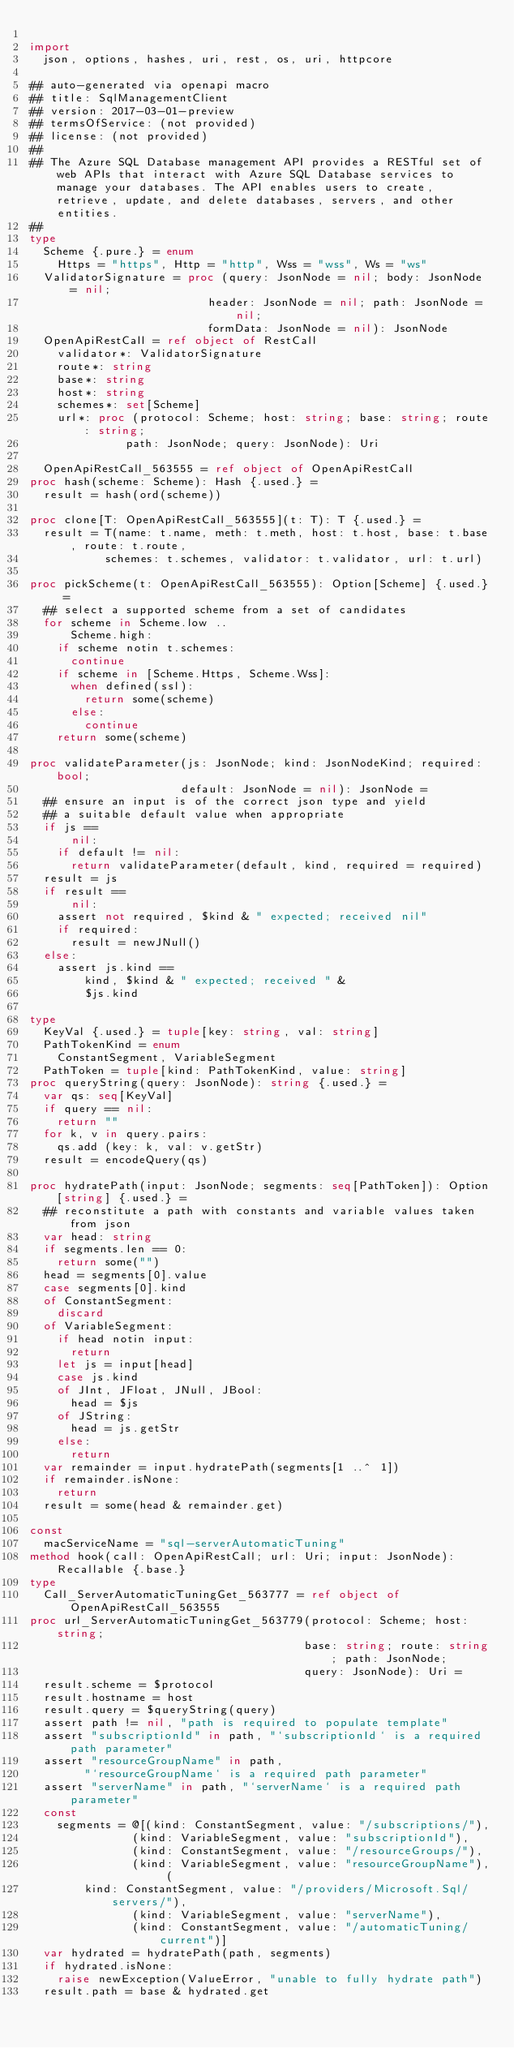<code> <loc_0><loc_0><loc_500><loc_500><_Nim_>
import
  json, options, hashes, uri, rest, os, uri, httpcore

## auto-generated via openapi macro
## title: SqlManagementClient
## version: 2017-03-01-preview
## termsOfService: (not provided)
## license: (not provided)
## 
## The Azure SQL Database management API provides a RESTful set of web APIs that interact with Azure SQL Database services to manage your databases. The API enables users to create, retrieve, update, and delete databases, servers, and other entities.
## 
type
  Scheme {.pure.} = enum
    Https = "https", Http = "http", Wss = "wss", Ws = "ws"
  ValidatorSignature = proc (query: JsonNode = nil; body: JsonNode = nil;
                          header: JsonNode = nil; path: JsonNode = nil;
                          formData: JsonNode = nil): JsonNode
  OpenApiRestCall = ref object of RestCall
    validator*: ValidatorSignature
    route*: string
    base*: string
    host*: string
    schemes*: set[Scheme]
    url*: proc (protocol: Scheme; host: string; base: string; route: string;
              path: JsonNode; query: JsonNode): Uri

  OpenApiRestCall_563555 = ref object of OpenApiRestCall
proc hash(scheme: Scheme): Hash {.used.} =
  result = hash(ord(scheme))

proc clone[T: OpenApiRestCall_563555](t: T): T {.used.} =
  result = T(name: t.name, meth: t.meth, host: t.host, base: t.base, route: t.route,
           schemes: t.schemes, validator: t.validator, url: t.url)

proc pickScheme(t: OpenApiRestCall_563555): Option[Scheme] {.used.} =
  ## select a supported scheme from a set of candidates
  for scheme in Scheme.low ..
      Scheme.high:
    if scheme notin t.schemes:
      continue
    if scheme in [Scheme.Https, Scheme.Wss]:
      when defined(ssl):
        return some(scheme)
      else:
        continue
    return some(scheme)

proc validateParameter(js: JsonNode; kind: JsonNodeKind; required: bool;
                      default: JsonNode = nil): JsonNode =
  ## ensure an input is of the correct json type and yield
  ## a suitable default value when appropriate
  if js ==
      nil:
    if default != nil:
      return validateParameter(default, kind, required = required)
  result = js
  if result ==
      nil:
    assert not required, $kind & " expected; received nil"
    if required:
      result = newJNull()
  else:
    assert js.kind ==
        kind, $kind & " expected; received " &
        $js.kind

type
  KeyVal {.used.} = tuple[key: string, val: string]
  PathTokenKind = enum
    ConstantSegment, VariableSegment
  PathToken = tuple[kind: PathTokenKind, value: string]
proc queryString(query: JsonNode): string {.used.} =
  var qs: seq[KeyVal]
  if query == nil:
    return ""
  for k, v in query.pairs:
    qs.add (key: k, val: v.getStr)
  result = encodeQuery(qs)

proc hydratePath(input: JsonNode; segments: seq[PathToken]): Option[string] {.used.} =
  ## reconstitute a path with constants and variable values taken from json
  var head: string
  if segments.len == 0:
    return some("")
  head = segments[0].value
  case segments[0].kind
  of ConstantSegment:
    discard
  of VariableSegment:
    if head notin input:
      return
    let js = input[head]
    case js.kind
    of JInt, JFloat, JNull, JBool:
      head = $js
    of JString:
      head = js.getStr
    else:
      return
  var remainder = input.hydratePath(segments[1 ..^ 1])
  if remainder.isNone:
    return
  result = some(head & remainder.get)

const
  macServiceName = "sql-serverAutomaticTuning"
method hook(call: OpenApiRestCall; url: Uri; input: JsonNode): Recallable {.base.}
type
  Call_ServerAutomaticTuningGet_563777 = ref object of OpenApiRestCall_563555
proc url_ServerAutomaticTuningGet_563779(protocol: Scheme; host: string;
                                        base: string; route: string; path: JsonNode;
                                        query: JsonNode): Uri =
  result.scheme = $protocol
  result.hostname = host
  result.query = $queryString(query)
  assert path != nil, "path is required to populate template"
  assert "subscriptionId" in path, "`subscriptionId` is a required path parameter"
  assert "resourceGroupName" in path,
        "`resourceGroupName` is a required path parameter"
  assert "serverName" in path, "`serverName` is a required path parameter"
  const
    segments = @[(kind: ConstantSegment, value: "/subscriptions/"),
               (kind: VariableSegment, value: "subscriptionId"),
               (kind: ConstantSegment, value: "/resourceGroups/"),
               (kind: VariableSegment, value: "resourceGroupName"), (
        kind: ConstantSegment, value: "/providers/Microsoft.Sql/servers/"),
               (kind: VariableSegment, value: "serverName"),
               (kind: ConstantSegment, value: "/automaticTuning/current")]
  var hydrated = hydratePath(path, segments)
  if hydrated.isNone:
    raise newException(ValueError, "unable to fully hydrate path")
  result.path = base & hydrated.get
</code> 